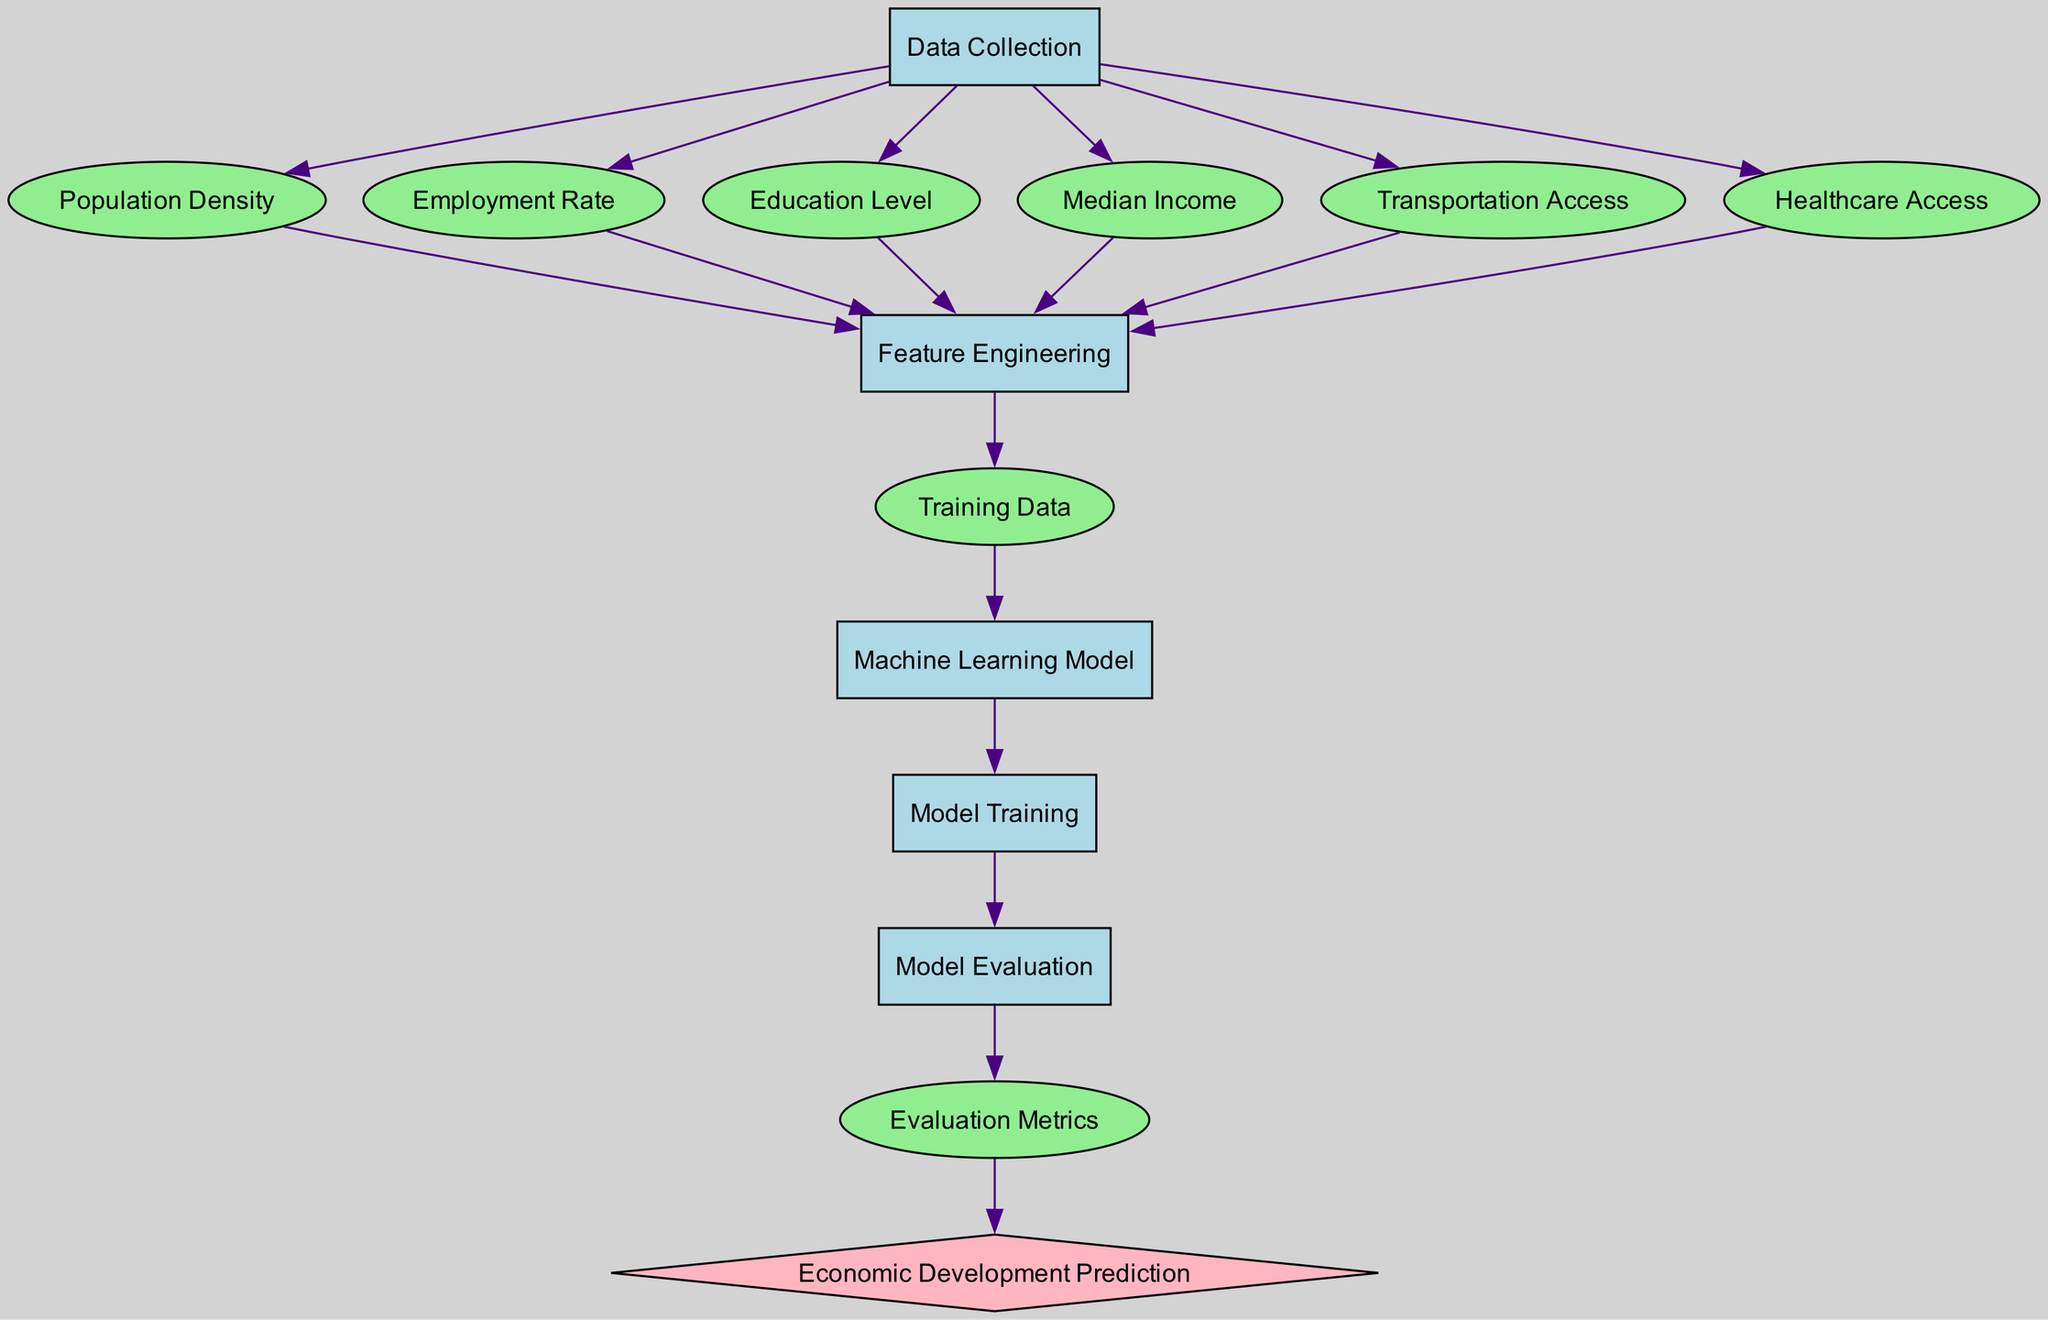What is the first step in the diagram? The first step listed in the diagram is "Data Collection," indicating that the process starts with gathering relevant data.
Answer: Data Collection How many data nodes are present? The diagram includes six data nodes: Population Density, Employment Rate, Education Level, Median Income, Transportation Access, and Healthcare Access. Adding these nodes together gives us six.
Answer: Six What is the output type of the diagram? The output of the diagram is represented as "Economic Development Prediction," categorized as an output type, which is typically a diamond shape in flow diagrams.
Answer: Economic Development Prediction Which process comes after Feature Engineering? Following Feature Engineering, the next process is "Training Data." The flow from Feature Engineering leads directly to the creation of Training Data.
Answer: Training Data What nodes contribute to Feature Engineering? Six nodes contribute to Feature Engineering: Population Density, Employment Rate, Education Level, Median Income, Transportation Access, and Healthcare Access, all feeding into this process.
Answer: Six How are evaluation metrics connected in this diagram? Evaluation Metrics are connected to Model Evaluation. After the model has been evaluated, the evaluation metrics are generated from this process, leading to the final output.
Answer: Model Evaluation What is the relationship between Training Data and the Machine Learning Model? The relationship is that Training Data is essential for training the Machine Learning Model; the Training Data node flows directly into the Machine Learning Model node in the diagram.
Answer: Essential Which node leads to Model Evaluation? The node that leads to Model Evaluation is "Model Training." After training the model, the next logical step is the evaluation of that model's performance.
Answer: Model Training 